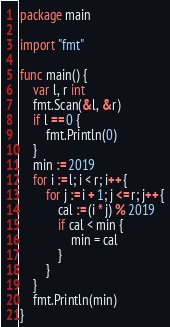<code> <loc_0><loc_0><loc_500><loc_500><_Go_>package main

import "fmt"

func main() {
	var l, r int
	fmt.Scan(&l, &r)
	if l == 0 {
		fmt.Println(0)
	}
	min := 2019
	for i := l; i < r; i++ {
		for j := i + 1; j <= r; j++ {
			cal := (i * j) % 2019
			if cal < min {
				min = cal
			}
		}
	}
	fmt.Println(min)
}
</code> 